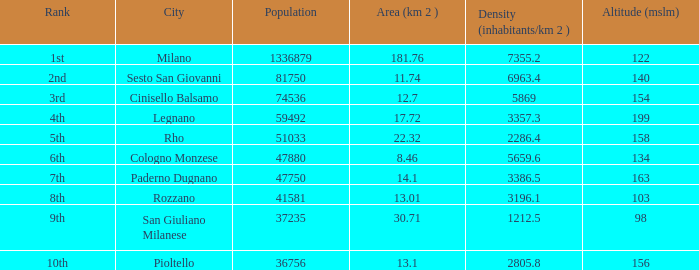What's the highest altitude (mslm) having an area (km 2) below 1 None. 